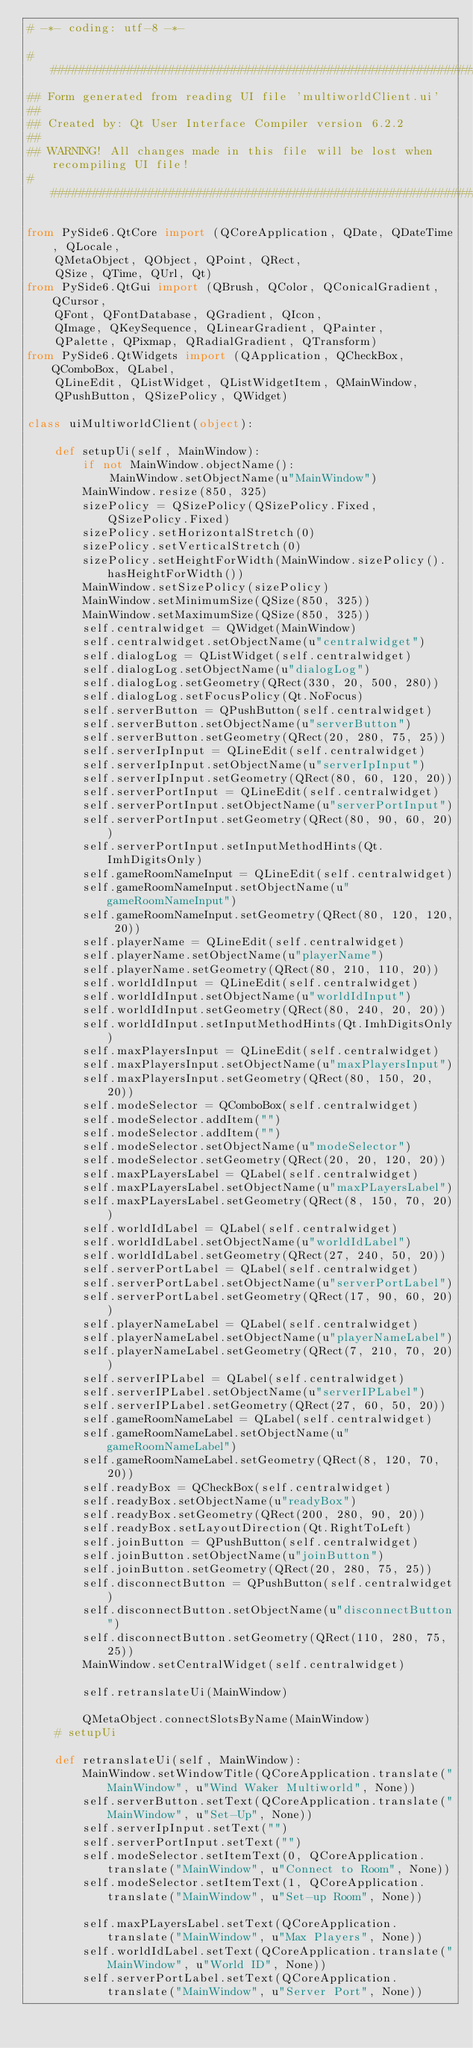Convert code to text. <code><loc_0><loc_0><loc_500><loc_500><_Python_># -*- coding: utf-8 -*-

################################################################################
## Form generated from reading UI file 'multiworldClient.ui'
##
## Created by: Qt User Interface Compiler version 6.2.2
##
## WARNING! All changes made in this file will be lost when recompiling UI file!
################################################################################

from PySide6.QtCore import (QCoreApplication, QDate, QDateTime, QLocale,
    QMetaObject, QObject, QPoint, QRect,
    QSize, QTime, QUrl, Qt)
from PySide6.QtGui import (QBrush, QColor, QConicalGradient, QCursor,
    QFont, QFontDatabase, QGradient, QIcon,
    QImage, QKeySequence, QLinearGradient, QPainter,
    QPalette, QPixmap, QRadialGradient, QTransform)
from PySide6.QtWidgets import (QApplication, QCheckBox, QComboBox, QLabel,
    QLineEdit, QListWidget, QListWidgetItem, QMainWindow,
    QPushButton, QSizePolicy, QWidget)

class uiMultiworldClient(object):
    
    def setupUi(self, MainWindow):
        if not MainWindow.objectName():
            MainWindow.setObjectName(u"MainWindow")
        MainWindow.resize(850, 325)
        sizePolicy = QSizePolicy(QSizePolicy.Fixed, QSizePolicy.Fixed)
        sizePolicy.setHorizontalStretch(0)
        sizePolicy.setVerticalStretch(0)
        sizePolicy.setHeightForWidth(MainWindow.sizePolicy().hasHeightForWidth())
        MainWindow.setSizePolicy(sizePolicy)
        MainWindow.setMinimumSize(QSize(850, 325))
        MainWindow.setMaximumSize(QSize(850, 325))
        self.centralwidget = QWidget(MainWindow)
        self.centralwidget.setObjectName(u"centralwidget")
        self.dialogLog = QListWidget(self.centralwidget)
        self.dialogLog.setObjectName(u"dialogLog")
        self.dialogLog.setGeometry(QRect(330, 20, 500, 280))
        self.dialogLog.setFocusPolicy(Qt.NoFocus)
        self.serverButton = QPushButton(self.centralwidget)
        self.serverButton.setObjectName(u"serverButton")
        self.serverButton.setGeometry(QRect(20, 280, 75, 25))
        self.serverIpInput = QLineEdit(self.centralwidget)
        self.serverIpInput.setObjectName(u"serverIpInput")
        self.serverIpInput.setGeometry(QRect(80, 60, 120, 20))
        self.serverPortInput = QLineEdit(self.centralwidget)
        self.serverPortInput.setObjectName(u"serverPortInput")
        self.serverPortInput.setGeometry(QRect(80, 90, 60, 20))
        self.serverPortInput.setInputMethodHints(Qt.ImhDigitsOnly)
        self.gameRoomNameInput = QLineEdit(self.centralwidget)
        self.gameRoomNameInput.setObjectName(u"gameRoomNameInput")
        self.gameRoomNameInput.setGeometry(QRect(80, 120, 120, 20))
        self.playerName = QLineEdit(self.centralwidget)
        self.playerName.setObjectName(u"playerName")
        self.playerName.setGeometry(QRect(80, 210, 110, 20))
        self.worldIdInput = QLineEdit(self.centralwidget)
        self.worldIdInput.setObjectName(u"worldIdInput")
        self.worldIdInput.setGeometry(QRect(80, 240, 20, 20))
        self.worldIdInput.setInputMethodHints(Qt.ImhDigitsOnly)
        self.maxPlayersInput = QLineEdit(self.centralwidget)
        self.maxPlayersInput.setObjectName(u"maxPlayersInput")
        self.maxPlayersInput.setGeometry(QRect(80, 150, 20, 20))
        self.modeSelector = QComboBox(self.centralwidget)
        self.modeSelector.addItem("")
        self.modeSelector.addItem("")
        self.modeSelector.setObjectName(u"modeSelector")
        self.modeSelector.setGeometry(QRect(20, 20, 120, 20))
        self.maxPLayersLabel = QLabel(self.centralwidget)
        self.maxPLayersLabel.setObjectName(u"maxPLayersLabel")
        self.maxPLayersLabel.setGeometry(QRect(8, 150, 70, 20))
        self.worldIdLabel = QLabel(self.centralwidget)
        self.worldIdLabel.setObjectName(u"worldIdLabel")
        self.worldIdLabel.setGeometry(QRect(27, 240, 50, 20))
        self.serverPortLabel = QLabel(self.centralwidget)
        self.serverPortLabel.setObjectName(u"serverPortLabel")
        self.serverPortLabel.setGeometry(QRect(17, 90, 60, 20))
        self.playerNameLabel = QLabel(self.centralwidget)
        self.playerNameLabel.setObjectName(u"playerNameLabel")
        self.playerNameLabel.setGeometry(QRect(7, 210, 70, 20))
        self.serverIPLabel = QLabel(self.centralwidget)
        self.serverIPLabel.setObjectName(u"serverIPLabel")
        self.serverIPLabel.setGeometry(QRect(27, 60, 50, 20))
        self.gameRoomNameLabel = QLabel(self.centralwidget)
        self.gameRoomNameLabel.setObjectName(u"gameRoomNameLabel")
        self.gameRoomNameLabel.setGeometry(QRect(8, 120, 70, 20))
        self.readyBox = QCheckBox(self.centralwidget)
        self.readyBox.setObjectName(u"readyBox")
        self.readyBox.setGeometry(QRect(200, 280, 90, 20))
        self.readyBox.setLayoutDirection(Qt.RightToLeft)
        self.joinButton = QPushButton(self.centralwidget)
        self.joinButton.setObjectName(u"joinButton")
        self.joinButton.setGeometry(QRect(20, 280, 75, 25))
        self.disconnectButton = QPushButton(self.centralwidget)
        self.disconnectButton.setObjectName(u"disconnectButton")
        self.disconnectButton.setGeometry(QRect(110, 280, 75, 25))
        MainWindow.setCentralWidget(self.centralwidget)

        self.retranslateUi(MainWindow)

        QMetaObject.connectSlotsByName(MainWindow)
    # setupUi

    def retranslateUi(self, MainWindow):
        MainWindow.setWindowTitle(QCoreApplication.translate("MainWindow", u"Wind Waker Multiworld", None))
        self.serverButton.setText(QCoreApplication.translate("MainWindow", u"Set-Up", None))
        self.serverIpInput.setText("")
        self.serverPortInput.setText("")
        self.modeSelector.setItemText(0, QCoreApplication.translate("MainWindow", u"Connect to Room", None))
        self.modeSelector.setItemText(1, QCoreApplication.translate("MainWindow", u"Set-up Room", None))

        self.maxPLayersLabel.setText(QCoreApplication.translate("MainWindow", u"Max Players", None))
        self.worldIdLabel.setText(QCoreApplication.translate("MainWindow", u"World ID", None))
        self.serverPortLabel.setText(QCoreApplication.translate("MainWindow", u"Server Port", None))</code> 